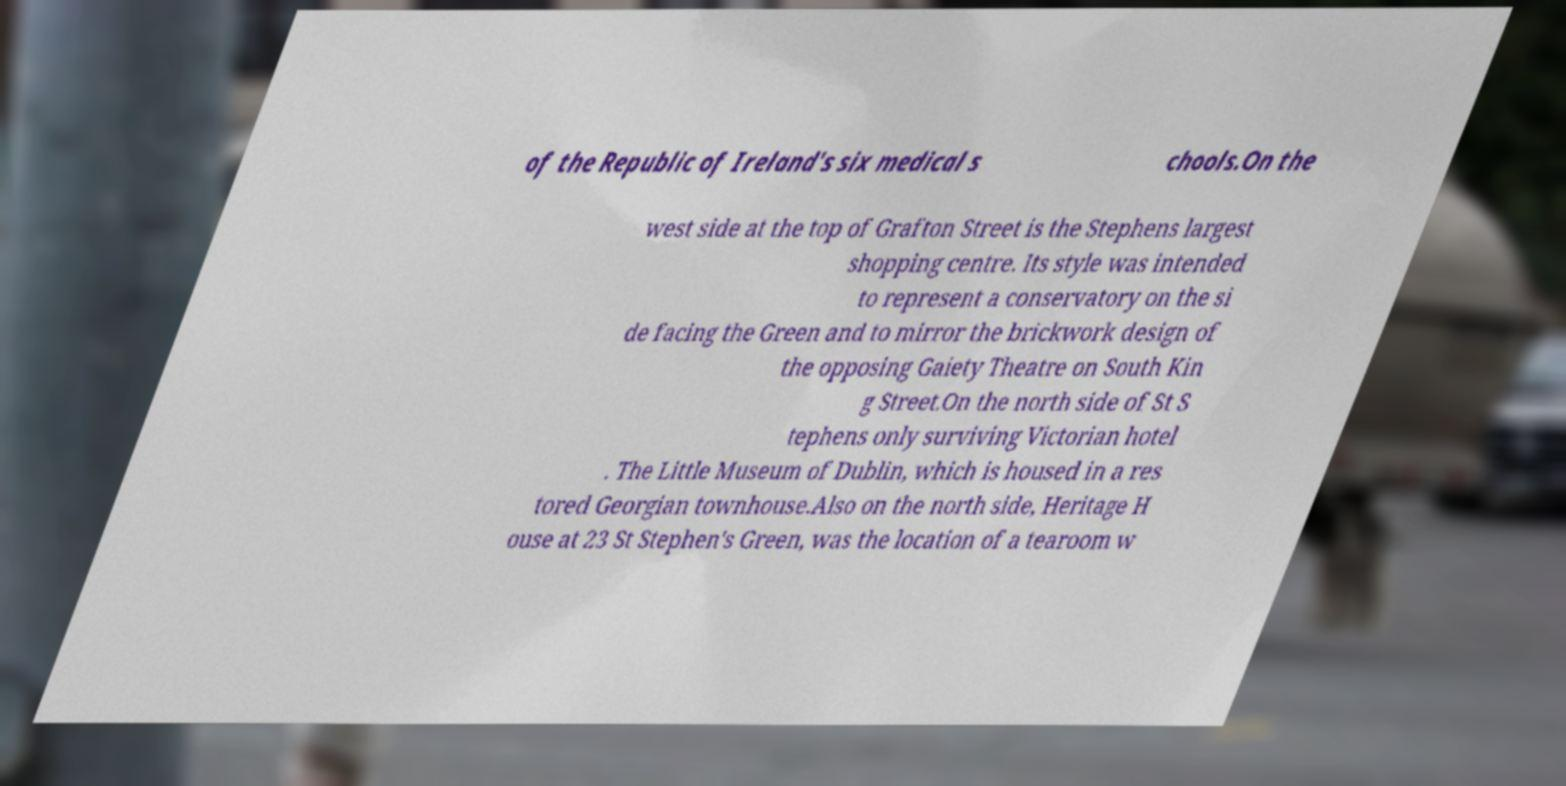Please identify and transcribe the text found in this image. of the Republic of Ireland's six medical s chools.On the west side at the top of Grafton Street is the Stephens largest shopping centre. Its style was intended to represent a conservatory on the si de facing the Green and to mirror the brickwork design of the opposing Gaiety Theatre on South Kin g Street.On the north side of St S tephens only surviving Victorian hotel . The Little Museum of Dublin, which is housed in a res tored Georgian townhouse.Also on the north side, Heritage H ouse at 23 St Stephen's Green, was the location of a tearoom w 